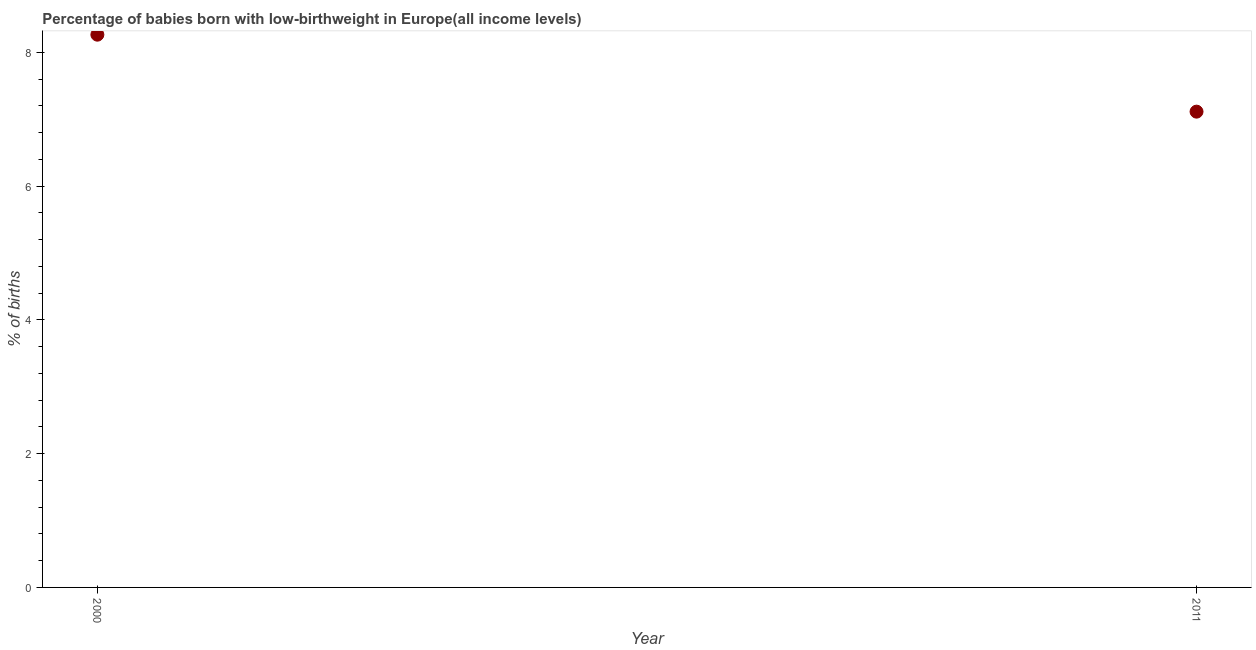What is the percentage of babies who were born with low-birthweight in 2011?
Provide a succinct answer. 7.12. Across all years, what is the maximum percentage of babies who were born with low-birthweight?
Provide a short and direct response. 8.27. Across all years, what is the minimum percentage of babies who were born with low-birthweight?
Provide a short and direct response. 7.12. In which year was the percentage of babies who were born with low-birthweight minimum?
Keep it short and to the point. 2011. What is the sum of the percentage of babies who were born with low-birthweight?
Offer a very short reply. 15.38. What is the difference between the percentage of babies who were born with low-birthweight in 2000 and 2011?
Provide a short and direct response. 1.15. What is the average percentage of babies who were born with low-birthweight per year?
Your response must be concise. 7.69. What is the median percentage of babies who were born with low-birthweight?
Offer a very short reply. 7.69. In how many years, is the percentage of babies who were born with low-birthweight greater than 1.6 %?
Your response must be concise. 2. What is the ratio of the percentage of babies who were born with low-birthweight in 2000 to that in 2011?
Provide a short and direct response. 1.16. In how many years, is the percentage of babies who were born with low-birthweight greater than the average percentage of babies who were born with low-birthweight taken over all years?
Your answer should be very brief. 1. Does the percentage of babies who were born with low-birthweight monotonically increase over the years?
Provide a succinct answer. No. How many dotlines are there?
Offer a very short reply. 1. What is the difference between two consecutive major ticks on the Y-axis?
Offer a very short reply. 2. Are the values on the major ticks of Y-axis written in scientific E-notation?
Your answer should be compact. No. Does the graph contain any zero values?
Provide a short and direct response. No. Does the graph contain grids?
Your response must be concise. No. What is the title of the graph?
Keep it short and to the point. Percentage of babies born with low-birthweight in Europe(all income levels). What is the label or title of the Y-axis?
Make the answer very short. % of births. What is the % of births in 2000?
Ensure brevity in your answer.  8.27. What is the % of births in 2011?
Provide a short and direct response. 7.12. What is the difference between the % of births in 2000 and 2011?
Keep it short and to the point. 1.15. What is the ratio of the % of births in 2000 to that in 2011?
Provide a succinct answer. 1.16. 